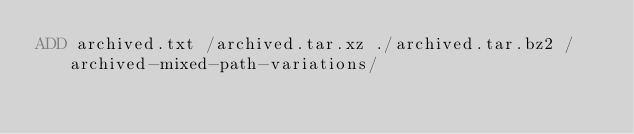<code> <loc_0><loc_0><loc_500><loc_500><_Dockerfile_>ADD archived.txt /archived.tar.xz ./archived.tar.bz2 /archived-mixed-path-variations/
</code> 